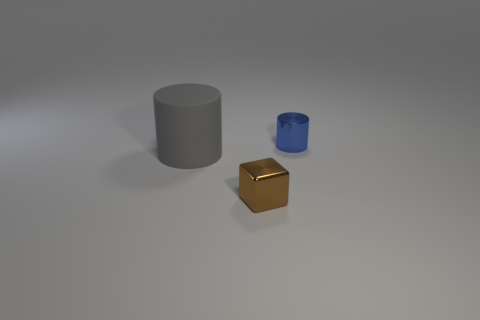Add 2 matte cylinders. How many objects exist? 5 Subtract all cylinders. How many objects are left? 1 Add 3 brown blocks. How many brown blocks exist? 4 Subtract 1 gray cylinders. How many objects are left? 2 Subtract all tiny red matte blocks. Subtract all blue shiny things. How many objects are left? 2 Add 2 shiny cubes. How many shiny cubes are left? 3 